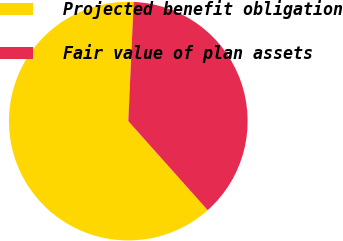Convert chart to OTSL. <chart><loc_0><loc_0><loc_500><loc_500><pie_chart><fcel>Projected benefit obligation<fcel>Fair value of plan assets<nl><fcel>62.31%<fcel>37.69%<nl></chart> 